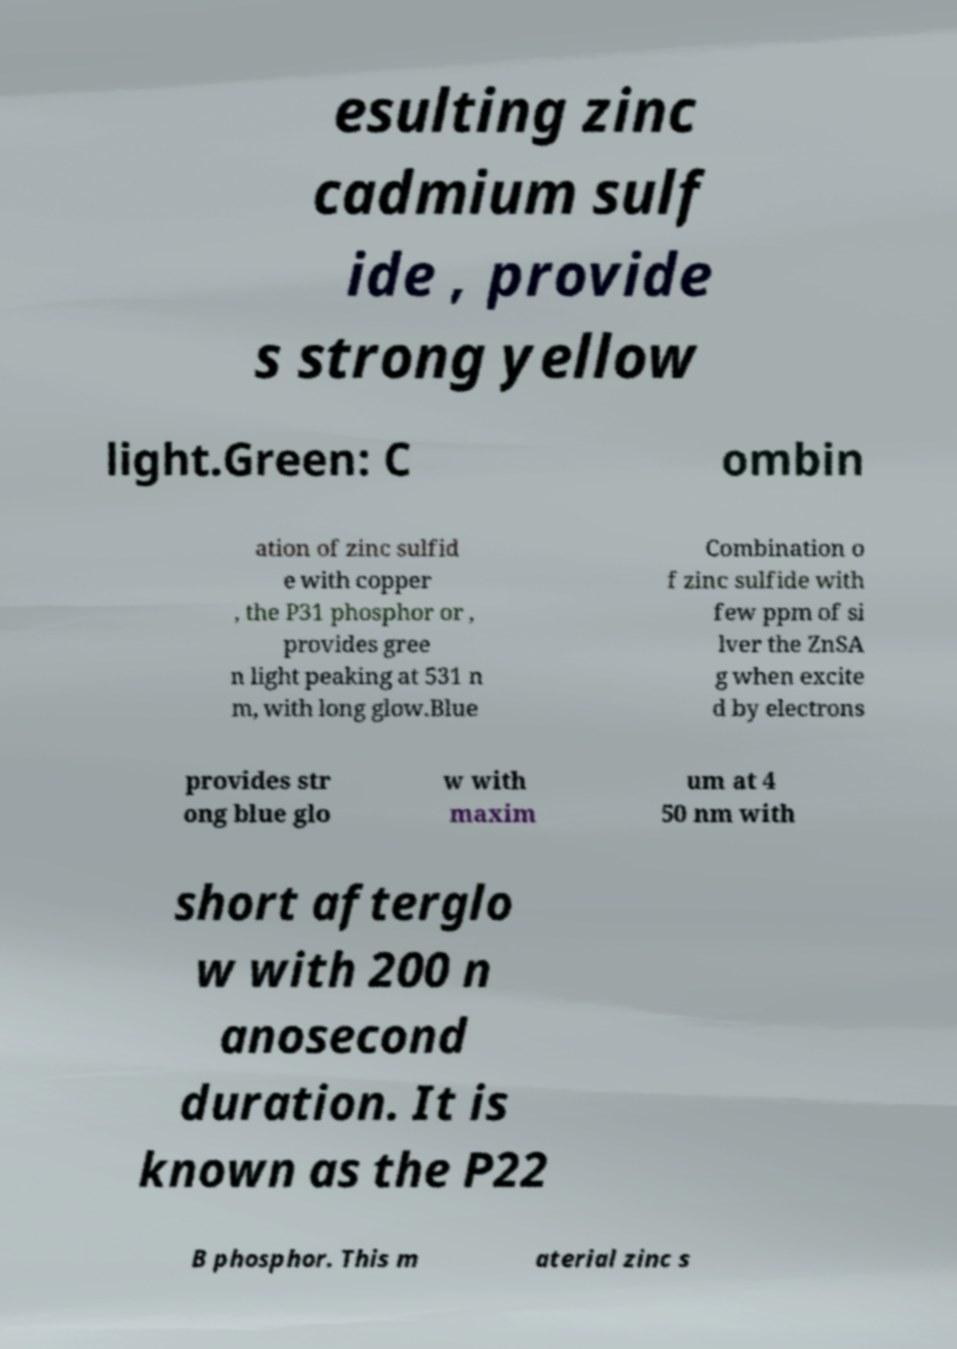Can you read and provide the text displayed in the image?This photo seems to have some interesting text. Can you extract and type it out for me? esulting zinc cadmium sulf ide , provide s strong yellow light.Green: C ombin ation of zinc sulfid e with copper , the P31 phosphor or , provides gree n light peaking at 531 n m, with long glow.Blue Combination o f zinc sulfide with few ppm of si lver the ZnSA g when excite d by electrons provides str ong blue glo w with maxim um at 4 50 nm with short afterglo w with 200 n anosecond duration. It is known as the P22 B phosphor. This m aterial zinc s 